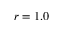Convert formula to latex. <formula><loc_0><loc_0><loc_500><loc_500>r = 1 . 0</formula> 